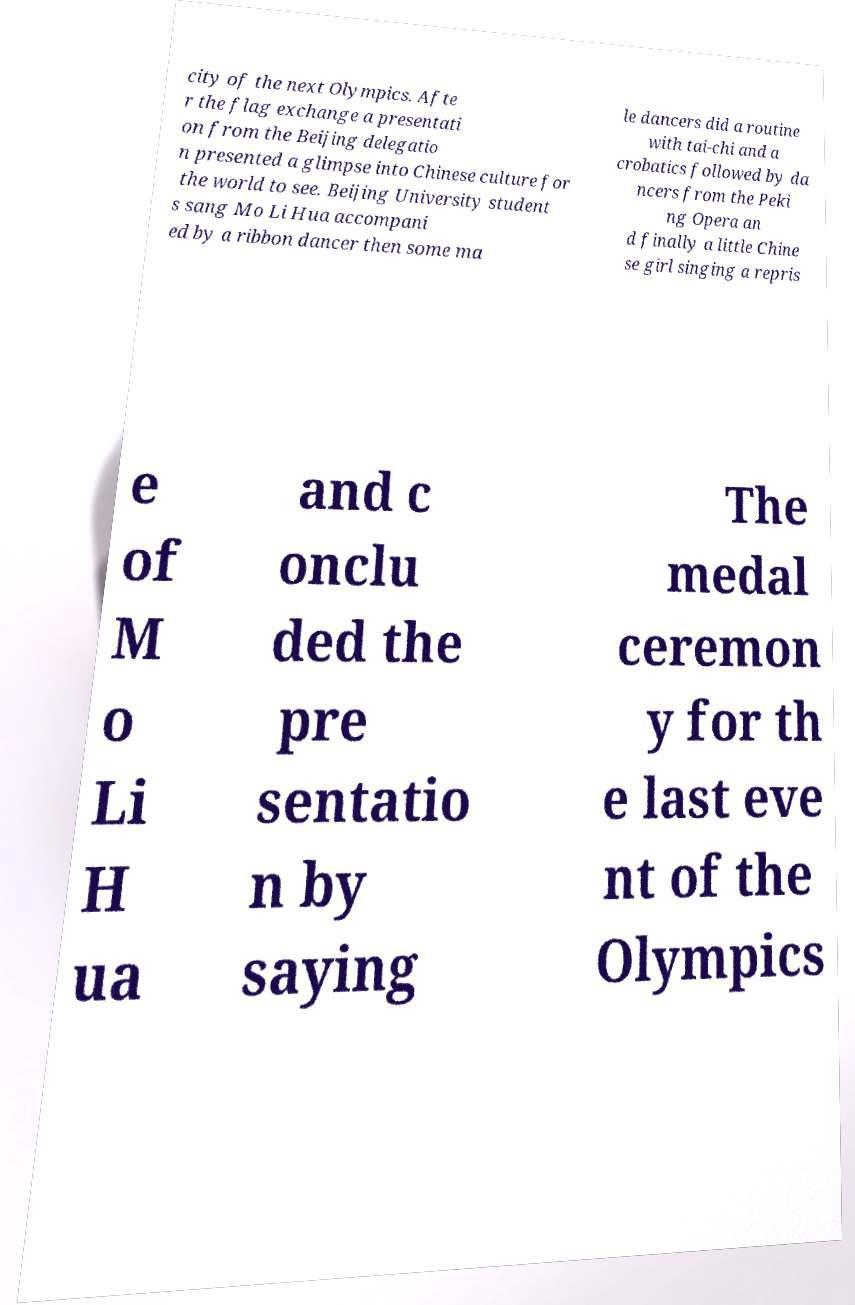Please read and relay the text visible in this image. What does it say? city of the next Olympics. Afte r the flag exchange a presentati on from the Beijing delegatio n presented a glimpse into Chinese culture for the world to see. Beijing University student s sang Mo Li Hua accompani ed by a ribbon dancer then some ma le dancers did a routine with tai-chi and a crobatics followed by da ncers from the Peki ng Opera an d finally a little Chine se girl singing a repris e of M o Li H ua and c onclu ded the pre sentatio n by saying The medal ceremon y for th e last eve nt of the Olympics 